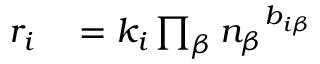Convert formula to latex. <formula><loc_0><loc_0><loc_500><loc_500>\begin{array} { r l } { r _ { i } } & = k _ { i } \prod _ { \beta } { n _ { \beta } } ^ { b _ { i \beta } } } \end{array}</formula> 